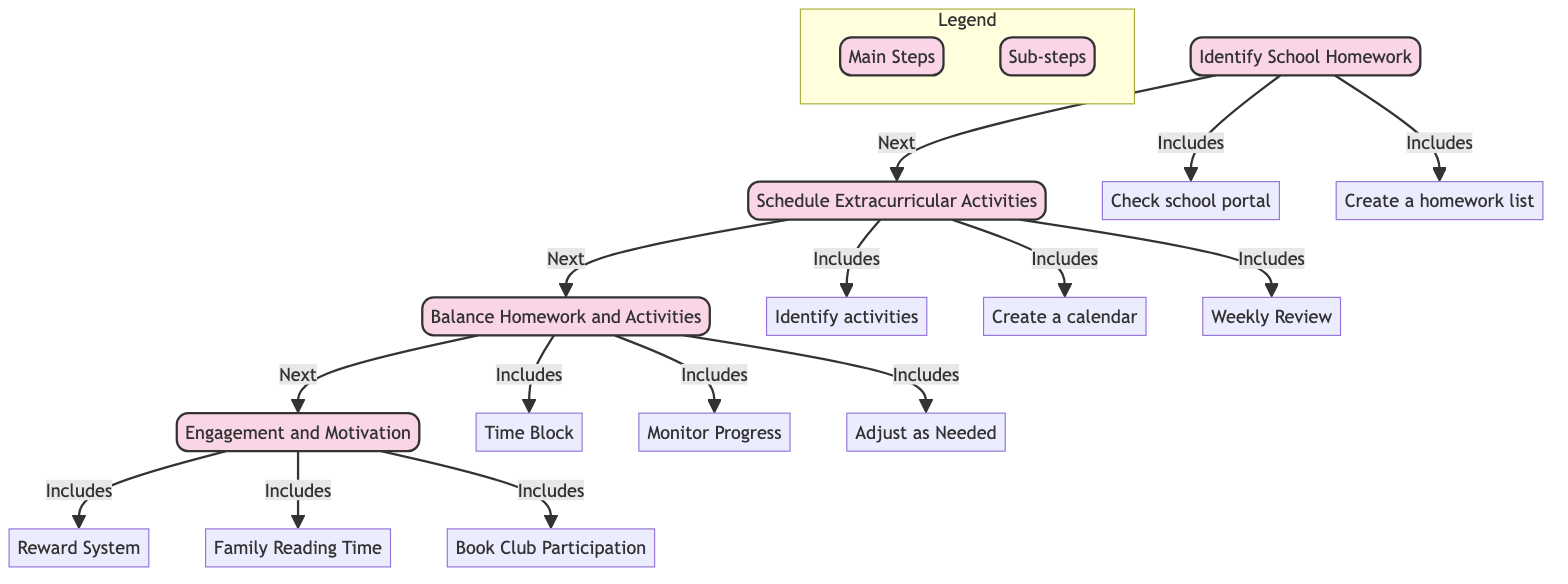What is the title of Node A? The title of Node A is clearly labeled in the diagram, indicating the initial step in the clinical pathway.
Answer: Identify School Homework How many main nodes are in the diagram? To find the number of main nodes, one can count the distinct sections labeled as Node A, Node B, Node C, and Node D in the flowchart.
Answer: 4 What is the next step after "Schedule Extracurricular Activities"? The flow of the diagram indicates a direct progression from scheduling to balancing activities and homework.
Answer: Balance Homework and Activities Which node includes the "Create a homework list" step? This step is directly included under Node A, which focuses on identifying school homework and related activities.
Answer: Node A What are the main activities included in Node D? By examining Node D, we can list the sub-activities that aim to keep children motivated and engaged, as clearly shown in the diagram.
Answer: Reward System, Family Reading Time, Book Club Participation What is the purpose of Node C? Analyzing Node C reveals its function in the overall pathway, where the main goal is to manage and balance homework and extracurricular activities.
Answer: Ensure children have time for both schoolwork and extracurriculars How often should the schedule be reviewed according to Node B? The diagram suggests that a weekly review is essential to make necessary adjustments to the extracurricular schedule.
Answer: Weekly What type of activities does Node B focus on? The activities identified in Node B are specifically related to those that occur outside of regular school hours and can include various types of engagement.
Answer: Extracurricular Activities What is indicated as a necessary adjustment process in Node C? Node C highlights the importance of flexibility in the scheduling process, suggesting adjustments may be needed based on children's needs.
Answer: Adjust as Needed 